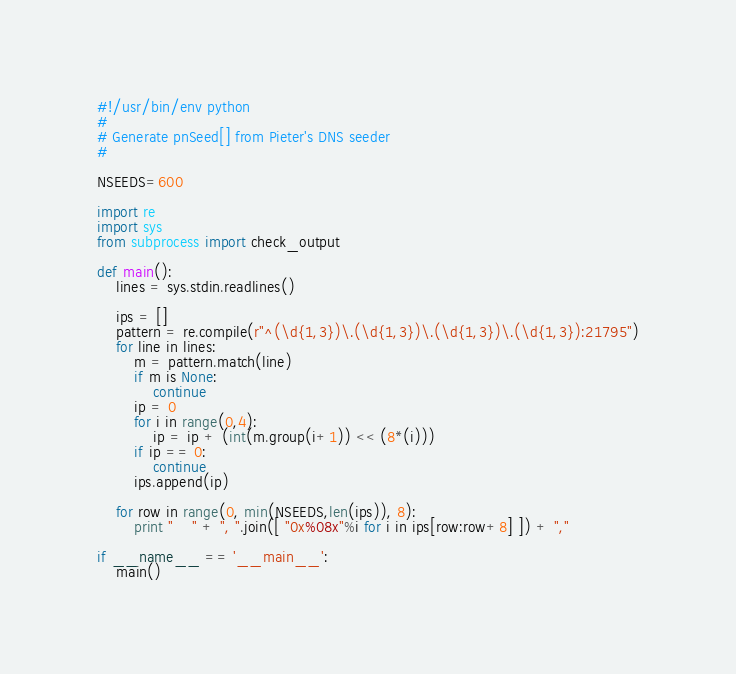Convert code to text. <code><loc_0><loc_0><loc_500><loc_500><_Python_>#!/usr/bin/env python
#
# Generate pnSeed[] from Pieter's DNS seeder
#

NSEEDS=600

import re
import sys
from subprocess import check_output

def main():
    lines = sys.stdin.readlines()

    ips = []
    pattern = re.compile(r"^(\d{1,3})\.(\d{1,3})\.(\d{1,3})\.(\d{1,3}):21795")
    for line in lines:
        m = pattern.match(line)
        if m is None:
            continue
        ip = 0
        for i in range(0,4):
            ip = ip + (int(m.group(i+1)) << (8*(i)))
        if ip == 0:
            continue
        ips.append(ip)

    for row in range(0, min(NSEEDS,len(ips)), 8):
        print "    " + ", ".join([ "0x%08x"%i for i in ips[row:row+8] ]) + ","

if __name__ == '__main__':
    main()
</code> 